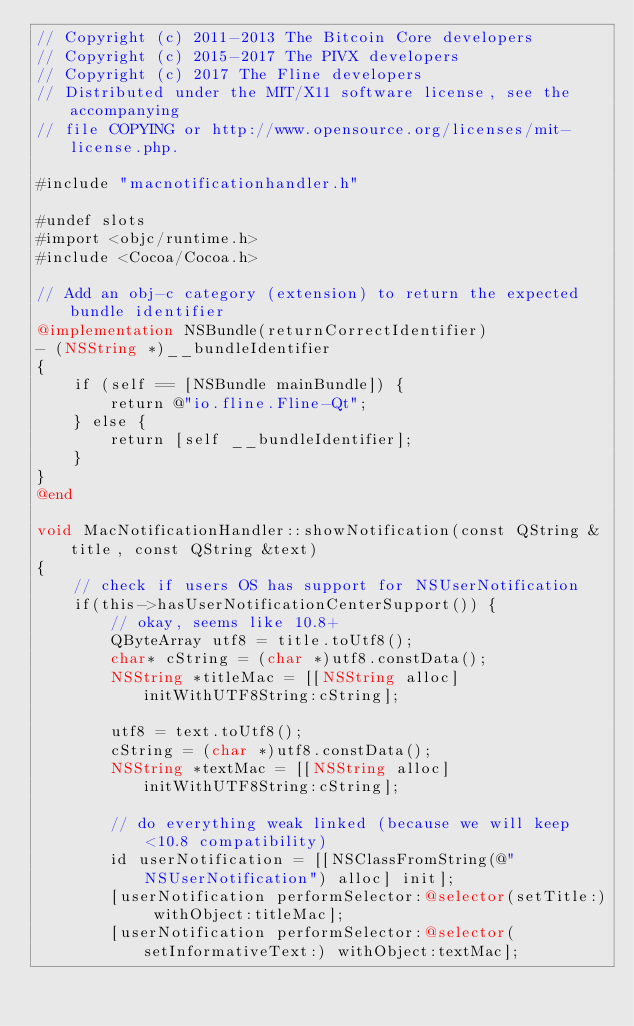Convert code to text. <code><loc_0><loc_0><loc_500><loc_500><_ObjectiveC_>// Copyright (c) 2011-2013 The Bitcoin Core developers
// Copyright (c) 2015-2017 The PIVX developers
// Copyright (c) 2017 The Fline developers
// Distributed under the MIT/X11 software license, see the accompanying
// file COPYING or http://www.opensource.org/licenses/mit-license.php.

#include "macnotificationhandler.h"

#undef slots
#import <objc/runtime.h>
#include <Cocoa/Cocoa.h>

// Add an obj-c category (extension) to return the expected bundle identifier
@implementation NSBundle(returnCorrectIdentifier)
- (NSString *)__bundleIdentifier
{
    if (self == [NSBundle mainBundle]) {
        return @"io.fline.Fline-Qt";
    } else {
        return [self __bundleIdentifier];
    }
}
@end

void MacNotificationHandler::showNotification(const QString &title, const QString &text)
{
    // check if users OS has support for NSUserNotification
    if(this->hasUserNotificationCenterSupport()) {
        // okay, seems like 10.8+
        QByteArray utf8 = title.toUtf8();
        char* cString = (char *)utf8.constData();
        NSString *titleMac = [[NSString alloc] initWithUTF8String:cString];

        utf8 = text.toUtf8();
        cString = (char *)utf8.constData();
        NSString *textMac = [[NSString alloc] initWithUTF8String:cString];

        // do everything weak linked (because we will keep <10.8 compatibility)
        id userNotification = [[NSClassFromString(@"NSUserNotification") alloc] init];
        [userNotification performSelector:@selector(setTitle:) withObject:titleMac];
        [userNotification performSelector:@selector(setInformativeText:) withObject:textMac];
</code> 